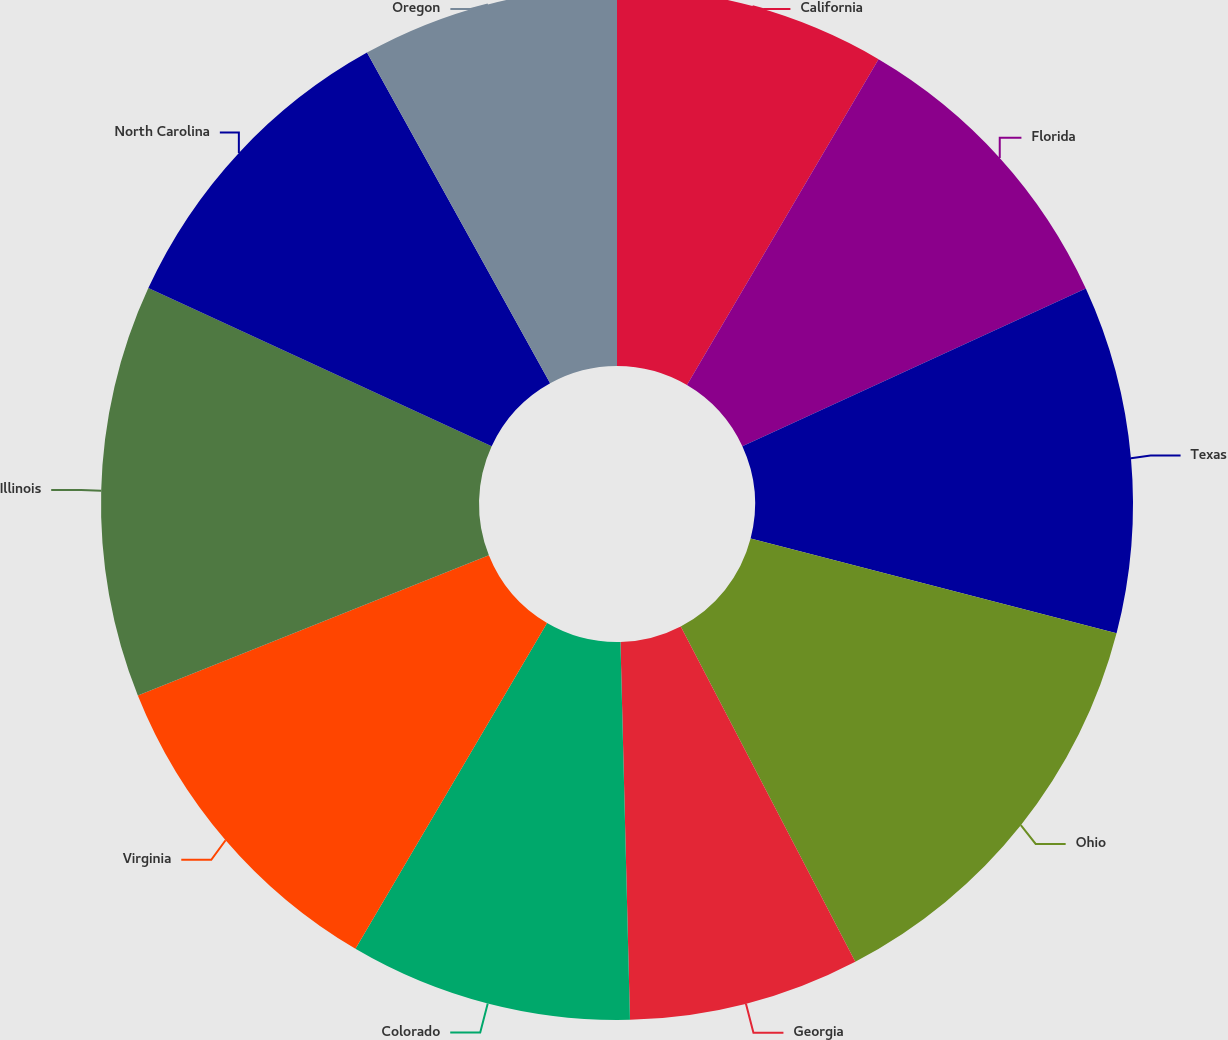<chart> <loc_0><loc_0><loc_500><loc_500><pie_chart><fcel>California<fcel>Florida<fcel>Texas<fcel>Ohio<fcel>Georgia<fcel>Colorado<fcel>Virginia<fcel>Illinois<fcel>North Carolina<fcel>Oregon<nl><fcel>8.46%<fcel>9.68%<fcel>10.89%<fcel>13.33%<fcel>7.24%<fcel>8.86%<fcel>10.49%<fcel>12.92%<fcel>10.08%<fcel>8.05%<nl></chart> 